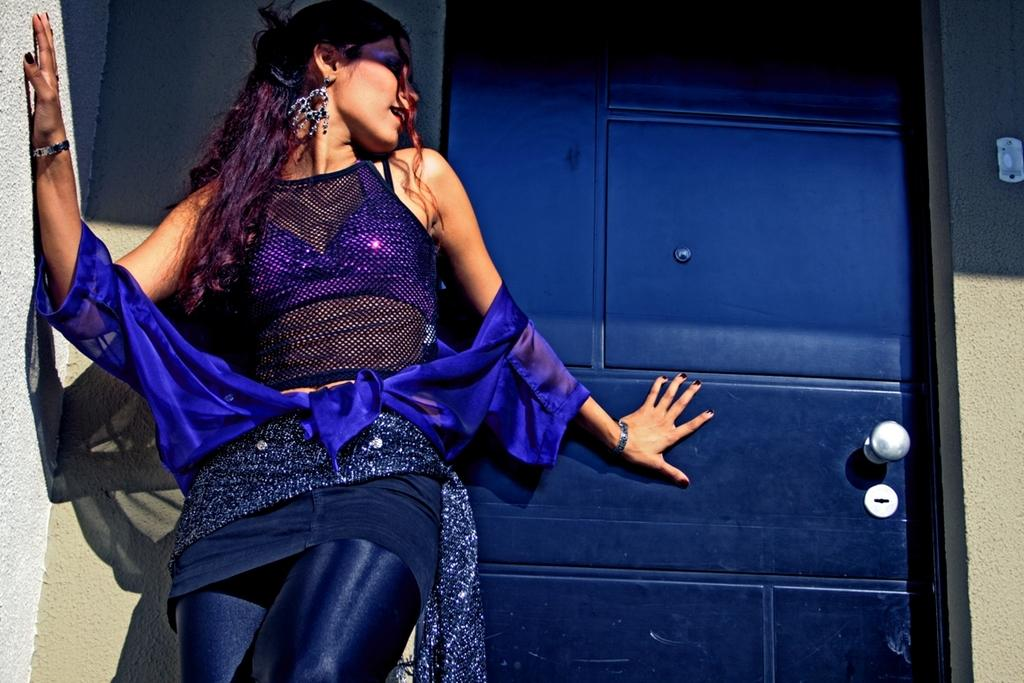Who is present in the image? There is a person in the image. What is the person wearing? The person is wearing a blue dress. What can be seen in the background of the image? There is a door and a wall in the background of the image. Can you see the person's uncle in the image? There is no mention of an uncle in the image, so it cannot be determined if the person's uncle is present. Are there any ants visible in the image? There is no mention of ants in the image, so it cannot be determined if any ants are present. 